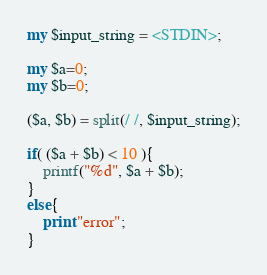<code> <loc_0><loc_0><loc_500><loc_500><_Perl_>
my $input_string = <STDIN>;

my $a=0;
my $b=0;

($a, $b) = split(/ /, $input_string);

if( ($a + $b) < 10 ){
	printf("%d", $a + $b);
}
else{
	print "error";
}</code> 